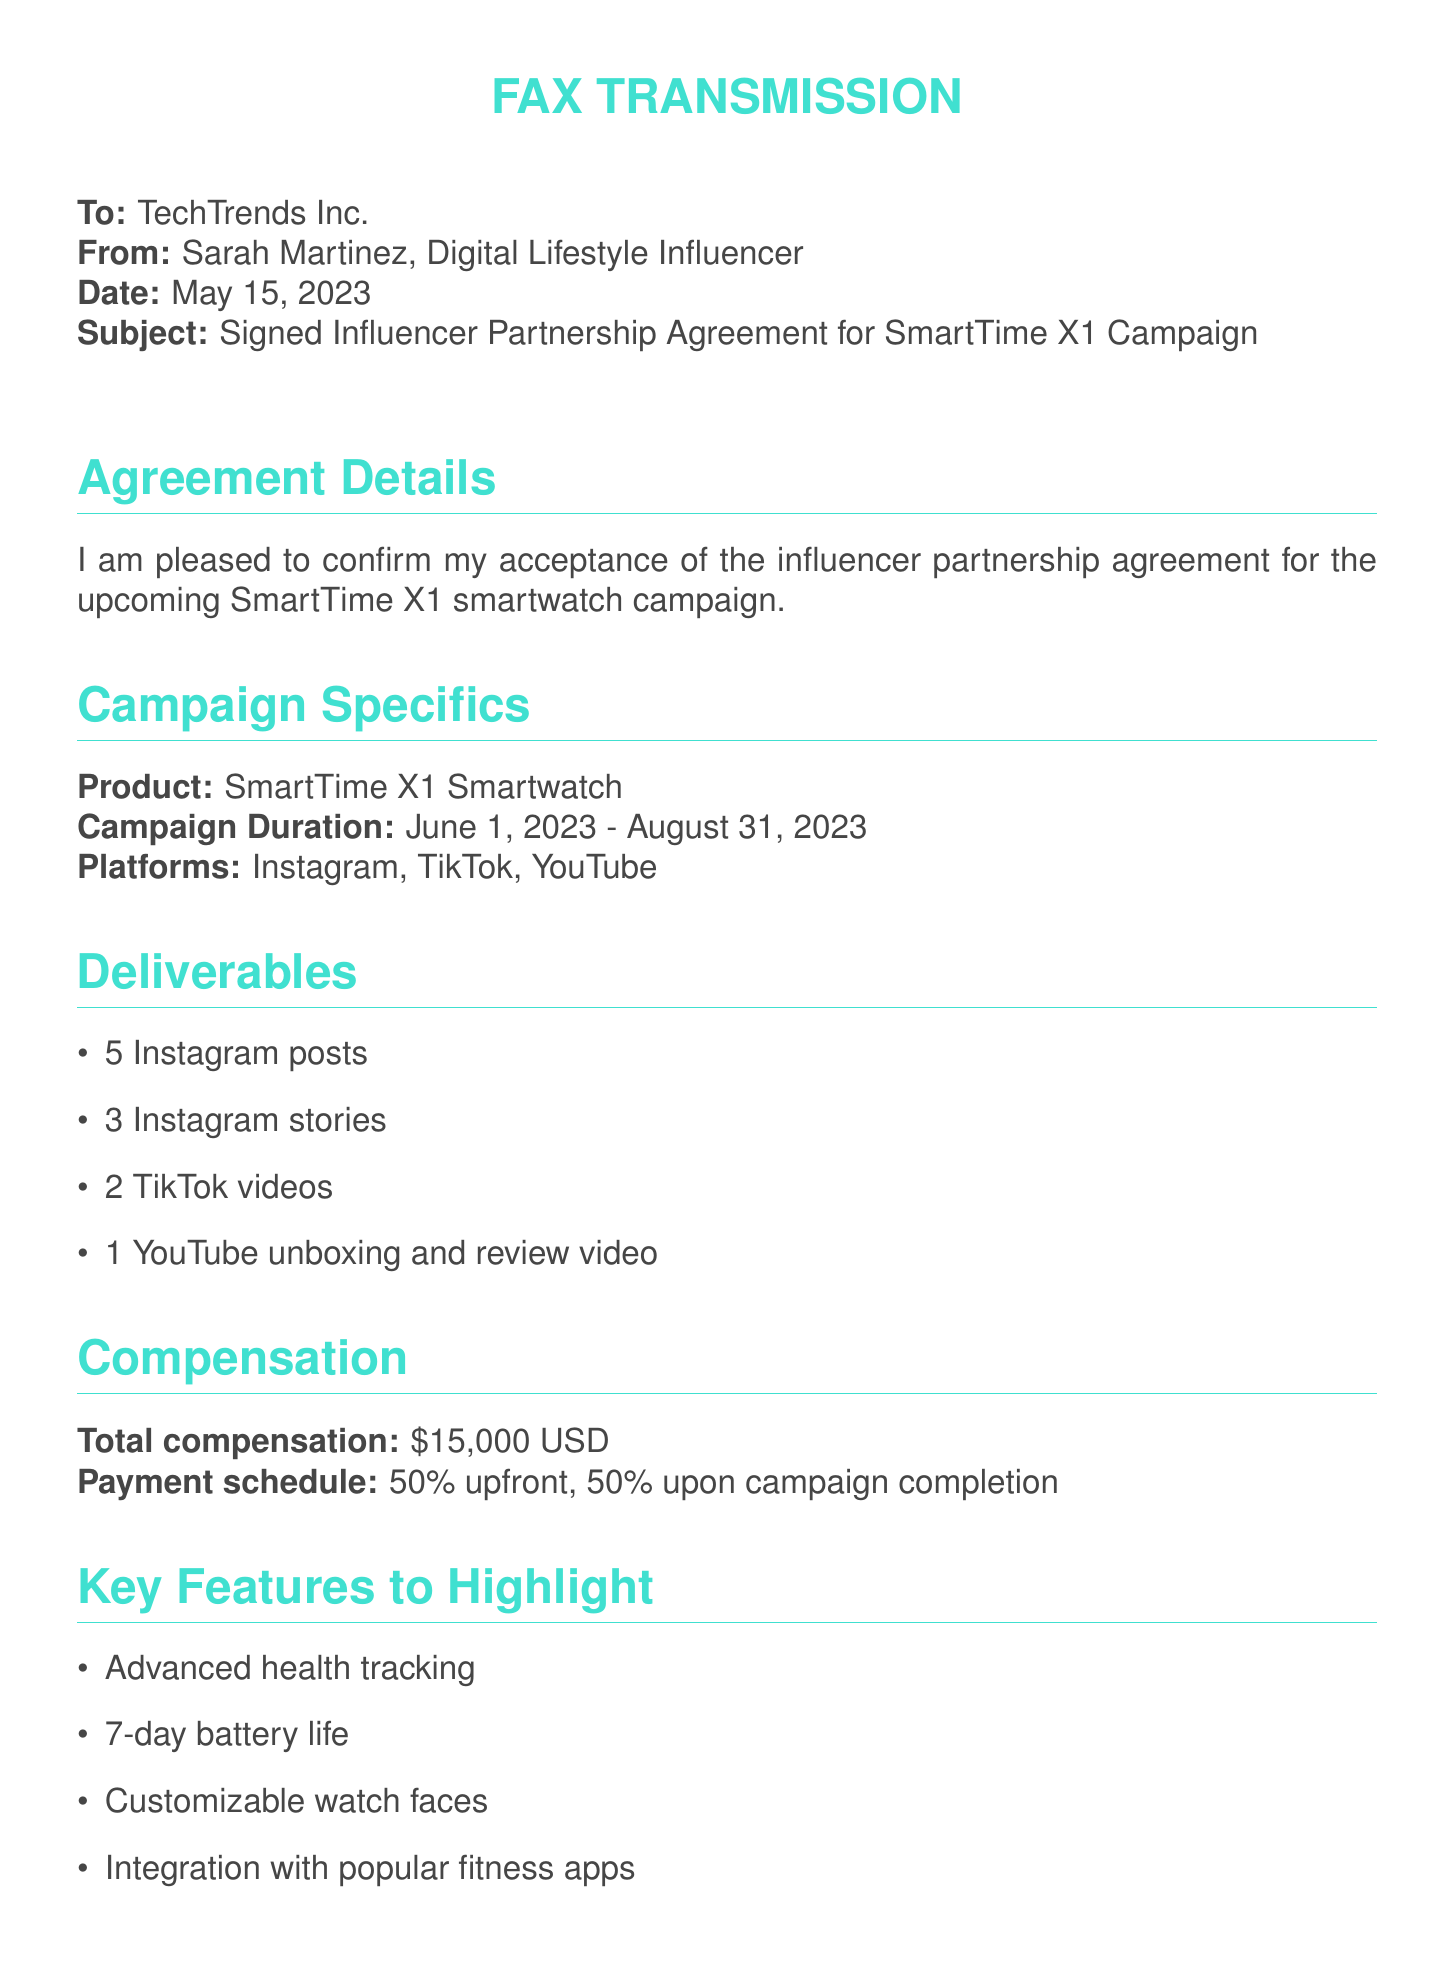What is the recipient's name? The document addresses TechTrends Inc., indicating this is the recipient's name.
Answer: TechTrends Inc Who is the sender? The sender's name is mentioned at the top of the document as Sarah Martinez.
Answer: Sarah Martinez What is the total compensation for the campaign? The compensation section states the total compensation is $15,000 USD.
Answer: $15,000 USD What are the campaign platforms? The platforms listed for the campaign include Instagram, TikTok, and YouTube.
Answer: Instagram, TikTok, YouTube How many Instagram posts are required? The deliverables section specifies the number of Instagram posts, which is 5.
Answer: 5 What is the campaign duration? The document outlines the campaign duration as starting from June 1, 2023 to August 31, 2023.
Answer: June 1, 2023 - August 31, 2023 What percentage of payment is made upfront? The payment schedule details that 50% of the total compensation is paid upfront.
Answer: 50% What key feature emphasizes health tracking? The key features section highlights "Advanced health tracking" as a feature to emphasize.
Answer: Advanced health tracking Which hashtag represents the partnership? The document includes the hashtag #TechTrendsPartner as representing the partnership.
Answer: #TechTrendsPartner 